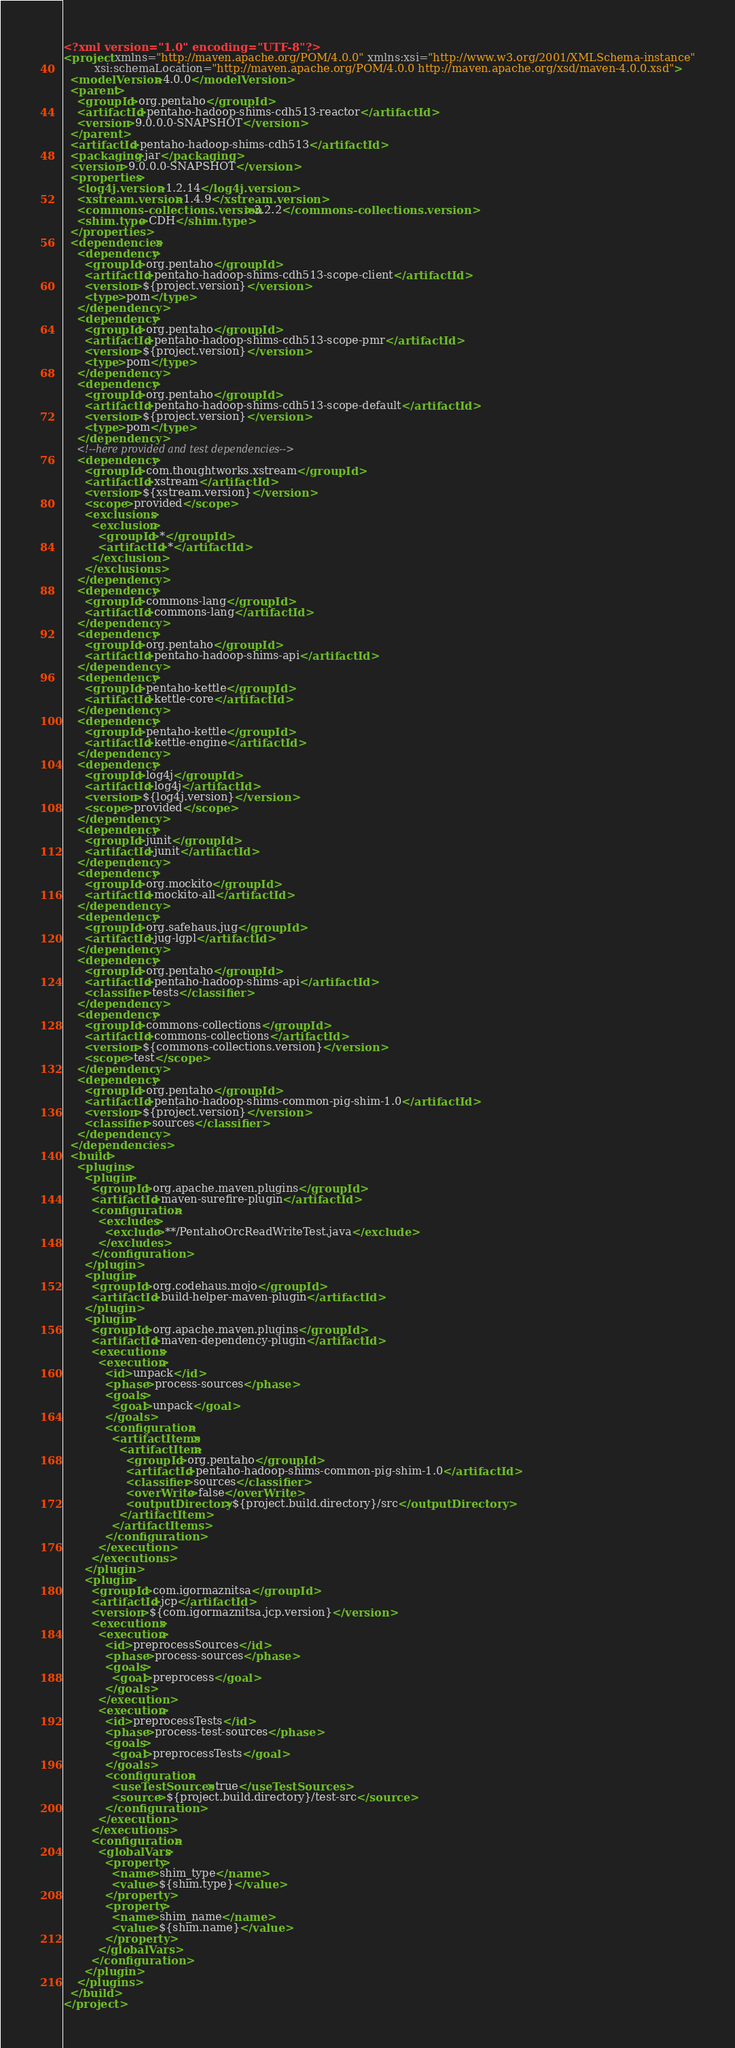<code> <loc_0><loc_0><loc_500><loc_500><_XML_><?xml version="1.0" encoding="UTF-8"?>
<project xmlns="http://maven.apache.org/POM/4.0.0" xmlns:xsi="http://www.w3.org/2001/XMLSchema-instance"
         xsi:schemaLocation="http://maven.apache.org/POM/4.0.0 http://maven.apache.org/xsd/maven-4.0.0.xsd">
  <modelVersion>4.0.0</modelVersion>
  <parent>
    <groupId>org.pentaho</groupId>
    <artifactId>pentaho-hadoop-shims-cdh513-reactor</artifactId>
    <version>9.0.0.0-SNAPSHOT</version>
  </parent>
  <artifactId>pentaho-hadoop-shims-cdh513</artifactId>
  <packaging>jar</packaging>
  <version>9.0.0.0-SNAPSHOT</version>
  <properties>
    <log4j.version>1.2.14</log4j.version>
    <xstream.version>1.4.9</xstream.version>
    <commons-collections.version>3.2.2</commons-collections.version>
    <shim.type>CDH</shim.type>
  </properties>
  <dependencies>
    <dependency>
      <groupId>org.pentaho</groupId>
      <artifactId>pentaho-hadoop-shims-cdh513-scope-client</artifactId>
      <version>${project.version}</version>
      <type>pom</type>
    </dependency>
    <dependency>
      <groupId>org.pentaho</groupId>
      <artifactId>pentaho-hadoop-shims-cdh513-scope-pmr</artifactId>
      <version>${project.version}</version>
      <type>pom</type>
    </dependency>
    <dependency>
      <groupId>org.pentaho</groupId>
      <artifactId>pentaho-hadoop-shims-cdh513-scope-default</artifactId>
      <version>${project.version}</version>
      <type>pom</type>
    </dependency>
    <!--here provided and test dependencies-->
    <dependency>
      <groupId>com.thoughtworks.xstream</groupId>
      <artifactId>xstream</artifactId>
      <version>${xstream.version}</version>
      <scope>provided</scope>
      <exclusions>
        <exclusion>
          <groupId>*</groupId>
          <artifactId>*</artifactId>
        </exclusion>
      </exclusions>
    </dependency>
    <dependency>
      <groupId>commons-lang</groupId>
      <artifactId>commons-lang</artifactId>
    </dependency>
    <dependency>
      <groupId>org.pentaho</groupId>
      <artifactId>pentaho-hadoop-shims-api</artifactId>
    </dependency>
    <dependency>
      <groupId>pentaho-kettle</groupId>
      <artifactId>kettle-core</artifactId>
    </dependency>
    <dependency>
      <groupId>pentaho-kettle</groupId>
      <artifactId>kettle-engine</artifactId>
    </dependency>
    <dependency>
      <groupId>log4j</groupId>
      <artifactId>log4j</artifactId>
      <version>${log4j.version}</version>
      <scope>provided</scope>
    </dependency>
    <dependency>
      <groupId>junit</groupId>
      <artifactId>junit</artifactId>
    </dependency>
    <dependency>
      <groupId>org.mockito</groupId>
      <artifactId>mockito-all</artifactId>
    </dependency>
    <dependency>
      <groupId>org.safehaus.jug</groupId>
      <artifactId>jug-lgpl</artifactId>
    </dependency>
    <dependency>
      <groupId>org.pentaho</groupId>
      <artifactId>pentaho-hadoop-shims-api</artifactId>
      <classifier>tests</classifier>
    </dependency>
    <dependency>
      <groupId>commons-collections</groupId>
      <artifactId>commons-collections</artifactId>
      <version>${commons-collections.version}</version>
      <scope>test</scope>
    </dependency>
    <dependency>
      <groupId>org.pentaho</groupId>
      <artifactId>pentaho-hadoop-shims-common-pig-shim-1.0</artifactId>
      <version>${project.version}</version>
      <classifier>sources</classifier>
    </dependency>
  </dependencies>
  <build>
    <plugins>
      <plugin>
        <groupId>org.apache.maven.plugins</groupId>
        <artifactId>maven-surefire-plugin</artifactId>
        <configuration>
          <excludes>
            <exclude>**/PentahoOrcReadWriteTest.java</exclude>
          </excludes>
        </configuration>
      </plugin>
      <plugin>
        <groupId>org.codehaus.mojo</groupId>
        <artifactId>build-helper-maven-plugin</artifactId>
      </plugin>
      <plugin>
        <groupId>org.apache.maven.plugins</groupId>
        <artifactId>maven-dependency-plugin</artifactId>
        <executions>
          <execution>
            <id>unpack</id>
            <phase>process-sources</phase>
            <goals>
              <goal>unpack</goal>
            </goals>
            <configuration>
              <artifactItems>
                <artifactItem>
                  <groupId>org.pentaho</groupId>
                  <artifactId>pentaho-hadoop-shims-common-pig-shim-1.0</artifactId>
                  <classifier>sources</classifier>
                  <overWrite>false</overWrite>
                  <outputDirectory>${project.build.directory}/src</outputDirectory>
                </artifactItem>
              </artifactItems>
            </configuration>
          </execution>
        </executions>
      </plugin>
      <plugin>
        <groupId>com.igormaznitsa</groupId>
        <artifactId>jcp</artifactId>
        <version>${com.igormaznitsa.jcp.version}</version>
        <executions>
          <execution>
            <id>preprocessSources</id>
            <phase>process-sources</phase>
            <goals>
              <goal>preprocess</goal>
            </goals>
          </execution>
          <execution>
            <id>preprocessTests</id>
            <phase>process-test-sources</phase>
            <goals>
              <goal>preprocessTests</goal>
            </goals>
            <configuration>
              <useTestSources>true</useTestSources>
              <source>${project.build.directory}/test-src</source>
            </configuration>
          </execution>
        </executions>
        <configuration>
          <globalVars>
            <property>
              <name>shim_type</name>
              <value>${shim.type}</value>
            </property>
            <property>
              <name>shim_name</name>
              <value>${shim.name}</value>
            </property>
          </globalVars>
        </configuration>
      </plugin>
    </plugins>
  </build>
</project>
</code> 